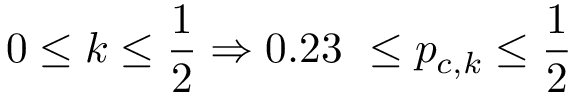Convert formula to latex. <formula><loc_0><loc_0><loc_500><loc_500>0 \leq k \leq \frac { 1 } { 2 } \Rightarrow 0 . 2 3 \ \leq p _ { c , k } \leq \frac { 1 } { 2 }</formula> 